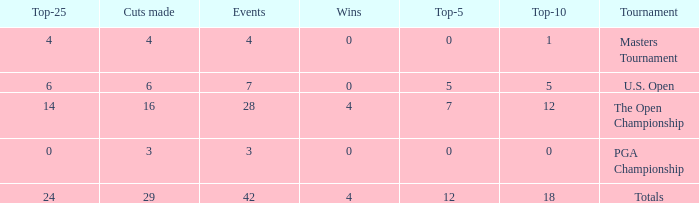What are the lowest top-5 with a top-25 larger than 4, 29 cuts and a top-10 larger than 18? None. 